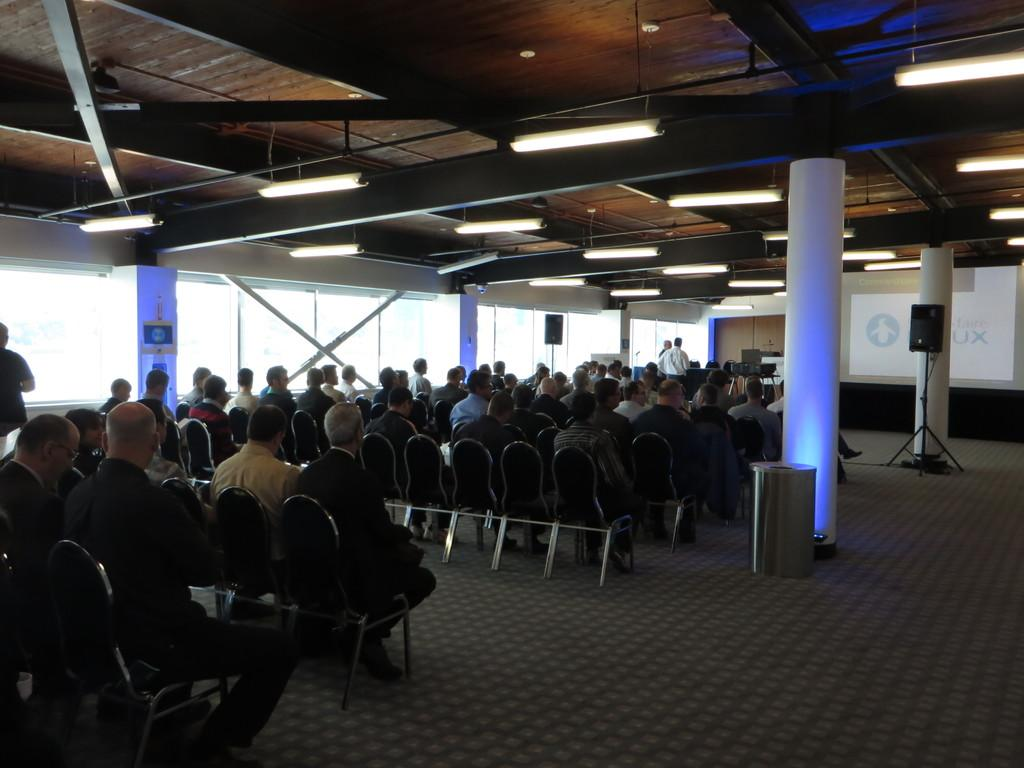What are the people in the image doing? The people in the image are sitting in chairs. What architectural features can be seen in the image? There are pillars in the image. What is located on the right side of the image? There is a screen on the right side of the image. What type of window is present on the left side of the image? There is a glass window on the left side of the image. What type of wool is being used to create the board in the image? There is no wool or board present in the image. 